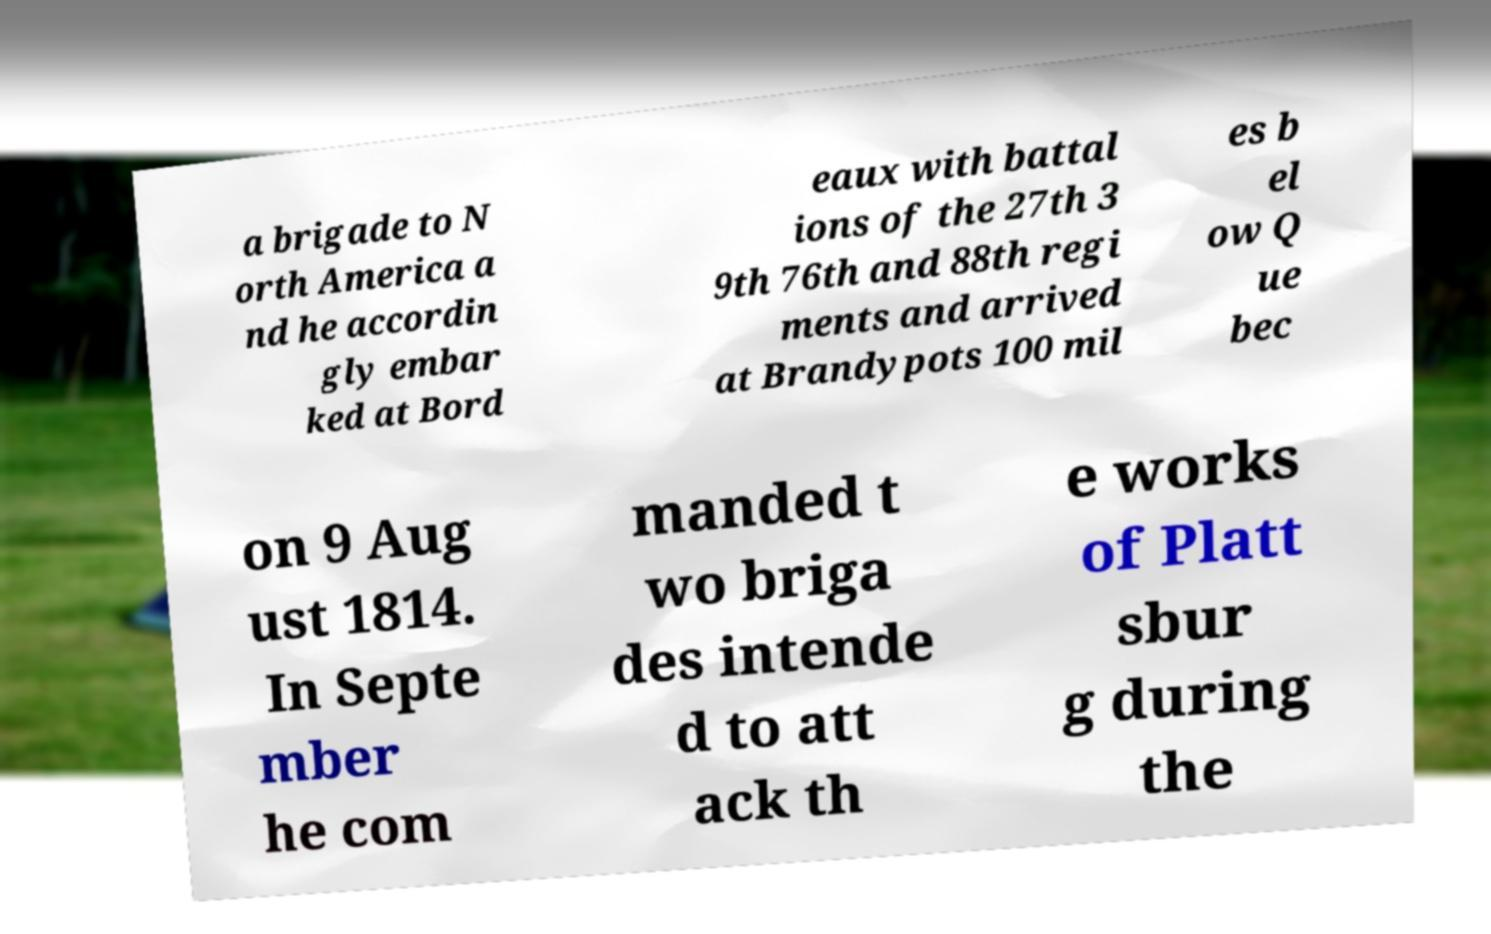There's text embedded in this image that I need extracted. Can you transcribe it verbatim? a brigade to N orth America a nd he accordin gly embar ked at Bord eaux with battal ions of the 27th 3 9th 76th and 88th regi ments and arrived at Brandypots 100 mil es b el ow Q ue bec on 9 Aug ust 1814. In Septe mber he com manded t wo briga des intende d to att ack th e works of Platt sbur g during the 